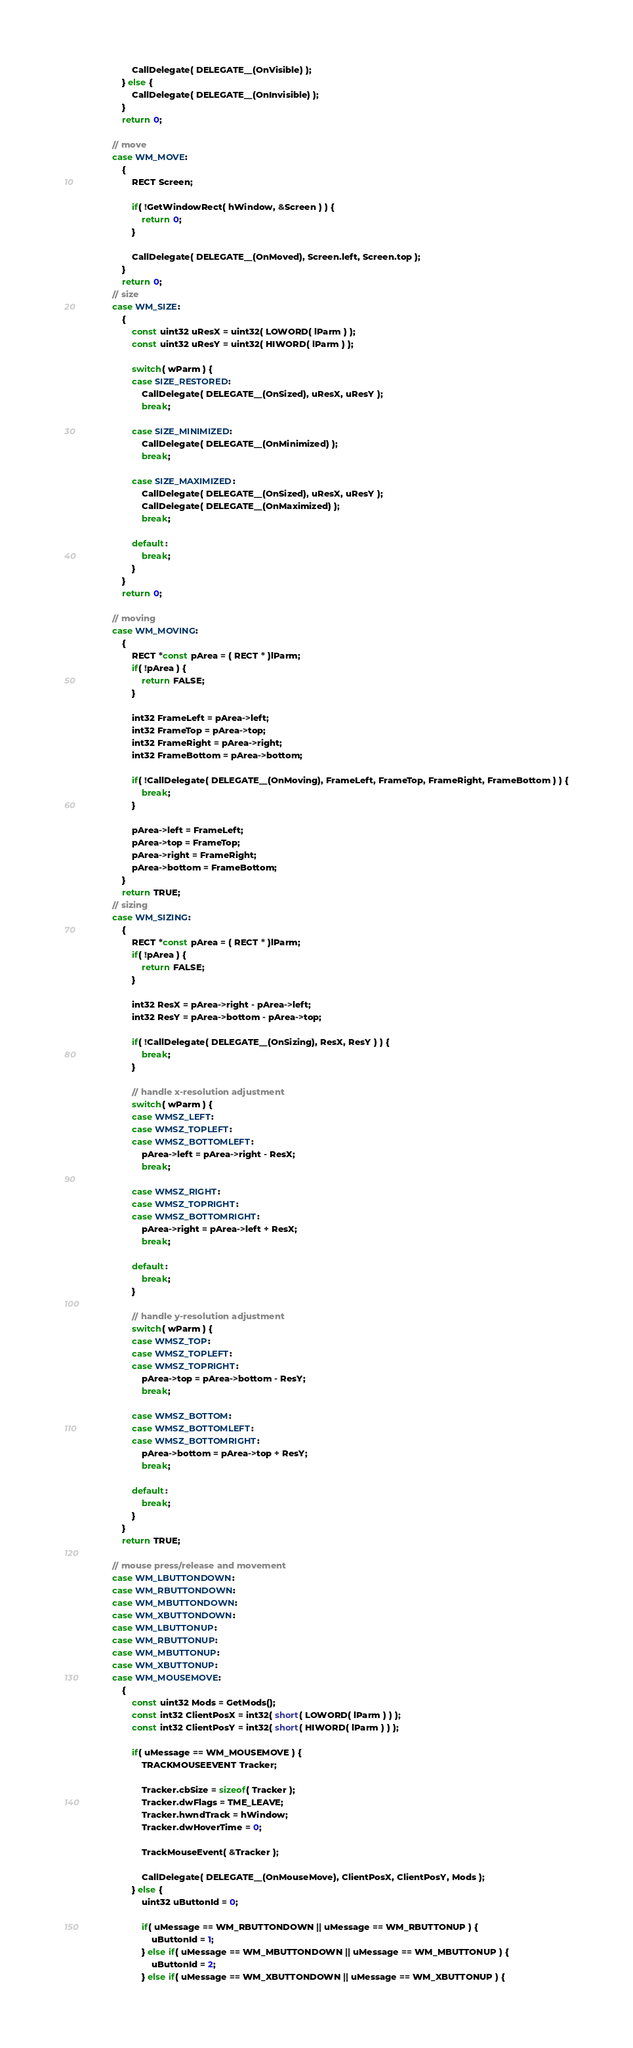Convert code to text. <code><loc_0><loc_0><loc_500><loc_500><_C++_>						CallDelegate( DELEGATE__(OnVisible) );
					} else {
						CallDelegate( DELEGATE__(OnInvisible) );
					}
					return 0;

				// move
				case WM_MOVE:
					{
						RECT Screen;

						if( !GetWindowRect( hWindow, &Screen ) ) {
							return 0;
						}

						CallDelegate( DELEGATE__(OnMoved), Screen.left, Screen.top );
					}
					return 0;
				// size
				case WM_SIZE:
					{
						const uint32 uResX = uint32( LOWORD( lParm ) );
						const uint32 uResY = uint32( HIWORD( lParm ) );

						switch( wParm ) {
						case SIZE_RESTORED:
							CallDelegate( DELEGATE__(OnSized), uResX, uResY );
							break;

						case SIZE_MINIMIZED:
							CallDelegate( DELEGATE__(OnMinimized) );
							break;

						case SIZE_MAXIMIZED:
							CallDelegate( DELEGATE__(OnSized), uResX, uResY );
							CallDelegate( DELEGATE__(OnMaximized) );
							break;

						default:
							break;
						}
					}
					return 0;

				// moving
				case WM_MOVING:
					{
						RECT *const pArea = ( RECT * )lParm;
						if( !pArea ) {
							return FALSE;
						}

						int32 FrameLeft = pArea->left;
						int32 FrameTop = pArea->top;
						int32 FrameRight = pArea->right;
						int32 FrameBottom = pArea->bottom;

						if( !CallDelegate( DELEGATE__(OnMoving), FrameLeft, FrameTop, FrameRight, FrameBottom ) ) {
							break;
						}

						pArea->left = FrameLeft;
						pArea->top = FrameTop;
						pArea->right = FrameRight;
						pArea->bottom = FrameBottom;
					}
					return TRUE;
				// sizing
				case WM_SIZING:
					{
						RECT *const pArea = ( RECT * )lParm;
						if( !pArea ) {
							return FALSE;
						}

						int32 ResX = pArea->right - pArea->left;
						int32 ResY = pArea->bottom - pArea->top;

						if( !CallDelegate( DELEGATE__(OnSizing), ResX, ResY ) ) {
							break;
						}

						// handle x-resolution adjustment
						switch( wParm ) {
						case WMSZ_LEFT:
						case WMSZ_TOPLEFT:
						case WMSZ_BOTTOMLEFT:
							pArea->left = pArea->right - ResX;
							break;

						case WMSZ_RIGHT:
						case WMSZ_TOPRIGHT:
						case WMSZ_BOTTOMRIGHT:
							pArea->right = pArea->left + ResX;
							break;

						default:
							break;
						}

						// handle y-resolution adjustment
						switch( wParm ) {
						case WMSZ_TOP:
						case WMSZ_TOPLEFT:
						case WMSZ_TOPRIGHT:
							pArea->top = pArea->bottom - ResY;
							break;

						case WMSZ_BOTTOM:
						case WMSZ_BOTTOMLEFT:
						case WMSZ_BOTTOMRIGHT:
							pArea->bottom = pArea->top + ResY;
							break;

						default:
							break;
						}
					}
					return TRUE;
					
				// mouse press/release and movement
				case WM_LBUTTONDOWN:
				case WM_RBUTTONDOWN:
				case WM_MBUTTONDOWN:
				case WM_XBUTTONDOWN:
				case WM_LBUTTONUP:
				case WM_RBUTTONUP:
				case WM_MBUTTONUP:
				case WM_XBUTTONUP:
				case WM_MOUSEMOVE:
					{
						const uint32 Mods = GetMods();
						const int32 ClientPosX = int32( short( LOWORD( lParm ) ) );
						const int32 ClientPosY = int32( short( HIWORD( lParm ) ) );

						if( uMessage == WM_MOUSEMOVE ) {
							TRACKMOUSEEVENT Tracker;

							Tracker.cbSize = sizeof( Tracker );
							Tracker.dwFlags = TME_LEAVE;
							Tracker.hwndTrack = hWindow;
							Tracker.dwHoverTime = 0;

							TrackMouseEvent( &Tracker );

							CallDelegate( DELEGATE__(OnMouseMove), ClientPosX, ClientPosY, Mods );
						} else {
							uint32 uButtonId = 0;

							if( uMessage == WM_RBUTTONDOWN || uMessage == WM_RBUTTONUP ) {
								uButtonId = 1;
							} else if( uMessage == WM_MBUTTONDOWN || uMessage == WM_MBUTTONUP ) {
								uButtonId = 2;
							} else if( uMessage == WM_XBUTTONDOWN || uMessage == WM_XBUTTONUP ) {</code> 